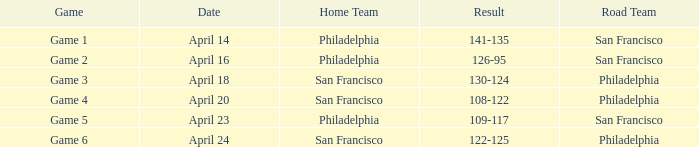What was the upshot of the contest conducted on april 16 with philadelphia as the home side? 126-95. 